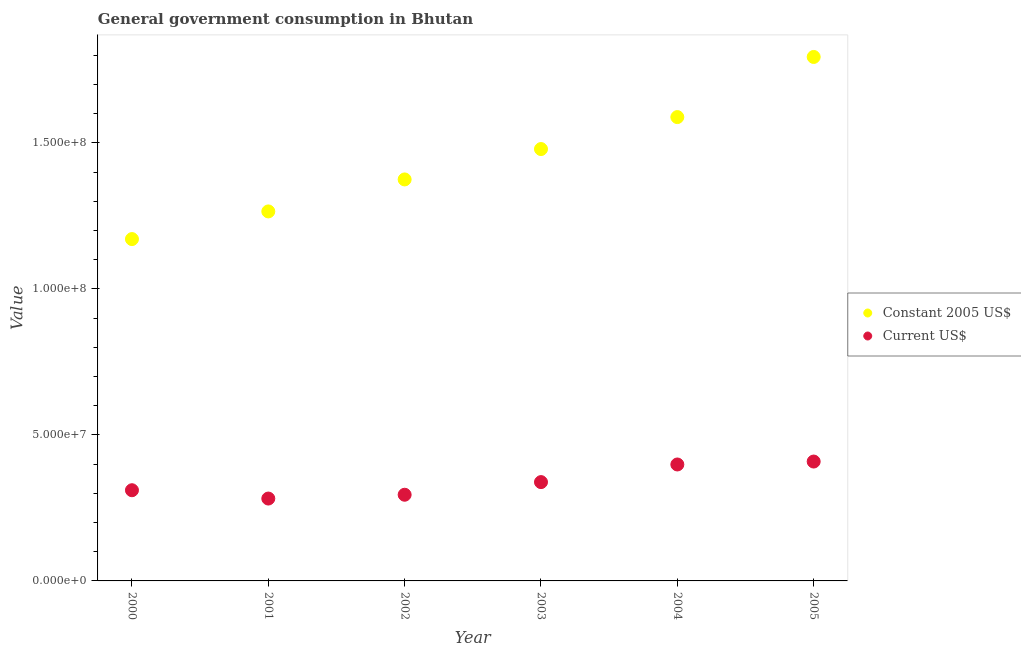How many different coloured dotlines are there?
Keep it short and to the point. 2. Is the number of dotlines equal to the number of legend labels?
Offer a very short reply. Yes. What is the value consumed in constant 2005 us$ in 2001?
Provide a succinct answer. 1.27e+08. Across all years, what is the maximum value consumed in constant 2005 us$?
Provide a succinct answer. 1.79e+08. Across all years, what is the minimum value consumed in current us$?
Your answer should be compact. 2.82e+07. In which year was the value consumed in current us$ maximum?
Your answer should be very brief. 2005. What is the total value consumed in constant 2005 us$ in the graph?
Make the answer very short. 8.67e+08. What is the difference between the value consumed in current us$ in 2001 and that in 2004?
Give a very brief answer. -1.17e+07. What is the difference between the value consumed in constant 2005 us$ in 2003 and the value consumed in current us$ in 2005?
Offer a terse response. 1.07e+08. What is the average value consumed in constant 2005 us$ per year?
Make the answer very short. 1.45e+08. In the year 2002, what is the difference between the value consumed in constant 2005 us$ and value consumed in current us$?
Provide a short and direct response. 1.08e+08. What is the ratio of the value consumed in constant 2005 us$ in 2000 to that in 2004?
Your response must be concise. 0.74. Is the value consumed in current us$ in 2002 less than that in 2005?
Your answer should be compact. Yes. What is the difference between the highest and the second highest value consumed in current us$?
Provide a short and direct response. 1.00e+06. What is the difference between the highest and the lowest value consumed in current us$?
Give a very brief answer. 1.27e+07. Is the sum of the value consumed in constant 2005 us$ in 2002 and 2005 greater than the maximum value consumed in current us$ across all years?
Ensure brevity in your answer.  Yes. Does the value consumed in current us$ monotonically increase over the years?
Keep it short and to the point. No. How many years are there in the graph?
Keep it short and to the point. 6. What is the difference between two consecutive major ticks on the Y-axis?
Provide a short and direct response. 5.00e+07. Are the values on the major ticks of Y-axis written in scientific E-notation?
Your answer should be very brief. Yes. Does the graph contain any zero values?
Provide a short and direct response. No. Does the graph contain grids?
Your answer should be very brief. No. How many legend labels are there?
Provide a succinct answer. 2. How are the legend labels stacked?
Offer a terse response. Vertical. What is the title of the graph?
Your response must be concise. General government consumption in Bhutan. Does "Resident workers" appear as one of the legend labels in the graph?
Offer a very short reply. No. What is the label or title of the Y-axis?
Give a very brief answer. Value. What is the Value of Constant 2005 US$ in 2000?
Your response must be concise. 1.17e+08. What is the Value of Current US$ in 2000?
Keep it short and to the point. 3.11e+07. What is the Value in Constant 2005 US$ in 2001?
Make the answer very short. 1.27e+08. What is the Value of Current US$ in 2001?
Offer a very short reply. 2.82e+07. What is the Value in Constant 2005 US$ in 2002?
Provide a succinct answer. 1.37e+08. What is the Value of Current US$ in 2002?
Provide a short and direct response. 2.95e+07. What is the Value of Constant 2005 US$ in 2003?
Give a very brief answer. 1.48e+08. What is the Value of Current US$ in 2003?
Offer a very short reply. 3.38e+07. What is the Value of Constant 2005 US$ in 2004?
Provide a succinct answer. 1.59e+08. What is the Value in Current US$ in 2004?
Keep it short and to the point. 3.99e+07. What is the Value in Constant 2005 US$ in 2005?
Offer a very short reply. 1.79e+08. What is the Value of Current US$ in 2005?
Your answer should be compact. 4.09e+07. Across all years, what is the maximum Value of Constant 2005 US$?
Make the answer very short. 1.79e+08. Across all years, what is the maximum Value in Current US$?
Give a very brief answer. 4.09e+07. Across all years, what is the minimum Value in Constant 2005 US$?
Keep it short and to the point. 1.17e+08. Across all years, what is the minimum Value in Current US$?
Your response must be concise. 2.82e+07. What is the total Value in Constant 2005 US$ in the graph?
Ensure brevity in your answer.  8.67e+08. What is the total Value in Current US$ in the graph?
Offer a very short reply. 2.03e+08. What is the difference between the Value in Constant 2005 US$ in 2000 and that in 2001?
Your response must be concise. -9.47e+06. What is the difference between the Value of Current US$ in 2000 and that in 2001?
Offer a very short reply. 2.85e+06. What is the difference between the Value of Constant 2005 US$ in 2000 and that in 2002?
Provide a short and direct response. -2.04e+07. What is the difference between the Value of Current US$ in 2000 and that in 2002?
Make the answer very short. 1.54e+06. What is the difference between the Value in Constant 2005 US$ in 2000 and that in 2003?
Your answer should be compact. -3.08e+07. What is the difference between the Value of Current US$ in 2000 and that in 2003?
Your response must be concise. -2.78e+06. What is the difference between the Value in Constant 2005 US$ in 2000 and that in 2004?
Offer a terse response. -4.18e+07. What is the difference between the Value in Current US$ in 2000 and that in 2004?
Keep it short and to the point. -8.82e+06. What is the difference between the Value of Constant 2005 US$ in 2000 and that in 2005?
Give a very brief answer. -6.24e+07. What is the difference between the Value of Current US$ in 2000 and that in 2005?
Provide a succinct answer. -9.82e+06. What is the difference between the Value in Constant 2005 US$ in 2001 and that in 2002?
Offer a very short reply. -1.10e+07. What is the difference between the Value in Current US$ in 2001 and that in 2002?
Your response must be concise. -1.30e+06. What is the difference between the Value of Constant 2005 US$ in 2001 and that in 2003?
Give a very brief answer. -2.14e+07. What is the difference between the Value in Current US$ in 2001 and that in 2003?
Keep it short and to the point. -5.63e+06. What is the difference between the Value of Constant 2005 US$ in 2001 and that in 2004?
Provide a succinct answer. -3.23e+07. What is the difference between the Value of Current US$ in 2001 and that in 2004?
Provide a succinct answer. -1.17e+07. What is the difference between the Value in Constant 2005 US$ in 2001 and that in 2005?
Keep it short and to the point. -5.29e+07. What is the difference between the Value in Current US$ in 2001 and that in 2005?
Offer a very short reply. -1.27e+07. What is the difference between the Value of Constant 2005 US$ in 2002 and that in 2003?
Give a very brief answer. -1.04e+07. What is the difference between the Value in Current US$ in 2002 and that in 2003?
Keep it short and to the point. -4.33e+06. What is the difference between the Value of Constant 2005 US$ in 2002 and that in 2004?
Provide a succinct answer. -2.13e+07. What is the difference between the Value in Current US$ in 2002 and that in 2004?
Make the answer very short. -1.04e+07. What is the difference between the Value of Constant 2005 US$ in 2002 and that in 2005?
Your response must be concise. -4.19e+07. What is the difference between the Value of Current US$ in 2002 and that in 2005?
Make the answer very short. -1.14e+07. What is the difference between the Value of Constant 2005 US$ in 2003 and that in 2004?
Give a very brief answer. -1.09e+07. What is the difference between the Value of Current US$ in 2003 and that in 2004?
Make the answer very short. -6.04e+06. What is the difference between the Value of Constant 2005 US$ in 2003 and that in 2005?
Give a very brief answer. -3.15e+07. What is the difference between the Value of Current US$ in 2003 and that in 2005?
Keep it short and to the point. -7.04e+06. What is the difference between the Value in Constant 2005 US$ in 2004 and that in 2005?
Your answer should be very brief. -2.06e+07. What is the difference between the Value of Current US$ in 2004 and that in 2005?
Your response must be concise. -1.00e+06. What is the difference between the Value in Constant 2005 US$ in 2000 and the Value in Current US$ in 2001?
Ensure brevity in your answer.  8.88e+07. What is the difference between the Value of Constant 2005 US$ in 2000 and the Value of Current US$ in 2002?
Your answer should be compact. 8.75e+07. What is the difference between the Value in Constant 2005 US$ in 2000 and the Value in Current US$ in 2003?
Keep it short and to the point. 8.32e+07. What is the difference between the Value of Constant 2005 US$ in 2000 and the Value of Current US$ in 2004?
Offer a very short reply. 7.72e+07. What is the difference between the Value in Constant 2005 US$ in 2000 and the Value in Current US$ in 2005?
Your response must be concise. 7.62e+07. What is the difference between the Value of Constant 2005 US$ in 2001 and the Value of Current US$ in 2002?
Provide a short and direct response. 9.70e+07. What is the difference between the Value in Constant 2005 US$ in 2001 and the Value in Current US$ in 2003?
Offer a very short reply. 9.27e+07. What is the difference between the Value in Constant 2005 US$ in 2001 and the Value in Current US$ in 2004?
Your answer should be compact. 8.66e+07. What is the difference between the Value of Constant 2005 US$ in 2001 and the Value of Current US$ in 2005?
Provide a short and direct response. 8.56e+07. What is the difference between the Value in Constant 2005 US$ in 2002 and the Value in Current US$ in 2003?
Provide a succinct answer. 1.04e+08. What is the difference between the Value in Constant 2005 US$ in 2002 and the Value in Current US$ in 2004?
Ensure brevity in your answer.  9.76e+07. What is the difference between the Value in Constant 2005 US$ in 2002 and the Value in Current US$ in 2005?
Offer a very short reply. 9.66e+07. What is the difference between the Value of Constant 2005 US$ in 2003 and the Value of Current US$ in 2004?
Your response must be concise. 1.08e+08. What is the difference between the Value of Constant 2005 US$ in 2003 and the Value of Current US$ in 2005?
Make the answer very short. 1.07e+08. What is the difference between the Value of Constant 2005 US$ in 2004 and the Value of Current US$ in 2005?
Provide a succinct answer. 1.18e+08. What is the average Value of Constant 2005 US$ per year?
Give a very brief answer. 1.45e+08. What is the average Value of Current US$ per year?
Keep it short and to the point. 3.39e+07. In the year 2000, what is the difference between the Value in Constant 2005 US$ and Value in Current US$?
Offer a very short reply. 8.60e+07. In the year 2001, what is the difference between the Value in Constant 2005 US$ and Value in Current US$?
Your response must be concise. 9.83e+07. In the year 2002, what is the difference between the Value of Constant 2005 US$ and Value of Current US$?
Offer a terse response. 1.08e+08. In the year 2003, what is the difference between the Value in Constant 2005 US$ and Value in Current US$?
Provide a succinct answer. 1.14e+08. In the year 2004, what is the difference between the Value of Constant 2005 US$ and Value of Current US$?
Give a very brief answer. 1.19e+08. In the year 2005, what is the difference between the Value in Constant 2005 US$ and Value in Current US$?
Give a very brief answer. 1.39e+08. What is the ratio of the Value in Constant 2005 US$ in 2000 to that in 2001?
Give a very brief answer. 0.93. What is the ratio of the Value in Current US$ in 2000 to that in 2001?
Your answer should be compact. 1.1. What is the ratio of the Value in Constant 2005 US$ in 2000 to that in 2002?
Ensure brevity in your answer.  0.85. What is the ratio of the Value in Current US$ in 2000 to that in 2002?
Your answer should be compact. 1.05. What is the ratio of the Value in Constant 2005 US$ in 2000 to that in 2003?
Give a very brief answer. 0.79. What is the ratio of the Value of Current US$ in 2000 to that in 2003?
Your answer should be very brief. 0.92. What is the ratio of the Value of Constant 2005 US$ in 2000 to that in 2004?
Your answer should be compact. 0.74. What is the ratio of the Value of Current US$ in 2000 to that in 2004?
Offer a terse response. 0.78. What is the ratio of the Value of Constant 2005 US$ in 2000 to that in 2005?
Offer a very short reply. 0.65. What is the ratio of the Value in Current US$ in 2000 to that in 2005?
Ensure brevity in your answer.  0.76. What is the ratio of the Value in Constant 2005 US$ in 2001 to that in 2002?
Offer a very short reply. 0.92. What is the ratio of the Value in Current US$ in 2001 to that in 2002?
Offer a terse response. 0.96. What is the ratio of the Value in Constant 2005 US$ in 2001 to that in 2003?
Provide a succinct answer. 0.86. What is the ratio of the Value in Current US$ in 2001 to that in 2003?
Offer a terse response. 0.83. What is the ratio of the Value in Constant 2005 US$ in 2001 to that in 2004?
Provide a succinct answer. 0.8. What is the ratio of the Value of Current US$ in 2001 to that in 2004?
Offer a very short reply. 0.71. What is the ratio of the Value of Constant 2005 US$ in 2001 to that in 2005?
Your answer should be very brief. 0.71. What is the ratio of the Value in Current US$ in 2001 to that in 2005?
Offer a terse response. 0.69. What is the ratio of the Value in Constant 2005 US$ in 2002 to that in 2003?
Make the answer very short. 0.93. What is the ratio of the Value of Current US$ in 2002 to that in 2003?
Make the answer very short. 0.87. What is the ratio of the Value in Constant 2005 US$ in 2002 to that in 2004?
Provide a succinct answer. 0.87. What is the ratio of the Value of Current US$ in 2002 to that in 2004?
Your answer should be very brief. 0.74. What is the ratio of the Value in Constant 2005 US$ in 2002 to that in 2005?
Ensure brevity in your answer.  0.77. What is the ratio of the Value in Current US$ in 2002 to that in 2005?
Offer a terse response. 0.72. What is the ratio of the Value in Constant 2005 US$ in 2003 to that in 2004?
Offer a terse response. 0.93. What is the ratio of the Value of Current US$ in 2003 to that in 2004?
Provide a short and direct response. 0.85. What is the ratio of the Value of Constant 2005 US$ in 2003 to that in 2005?
Provide a succinct answer. 0.82. What is the ratio of the Value of Current US$ in 2003 to that in 2005?
Make the answer very short. 0.83. What is the ratio of the Value of Constant 2005 US$ in 2004 to that in 2005?
Provide a short and direct response. 0.89. What is the ratio of the Value of Current US$ in 2004 to that in 2005?
Offer a very short reply. 0.98. What is the difference between the highest and the second highest Value in Constant 2005 US$?
Your answer should be compact. 2.06e+07. What is the difference between the highest and the second highest Value of Current US$?
Your answer should be compact. 1.00e+06. What is the difference between the highest and the lowest Value in Constant 2005 US$?
Your answer should be compact. 6.24e+07. What is the difference between the highest and the lowest Value in Current US$?
Keep it short and to the point. 1.27e+07. 